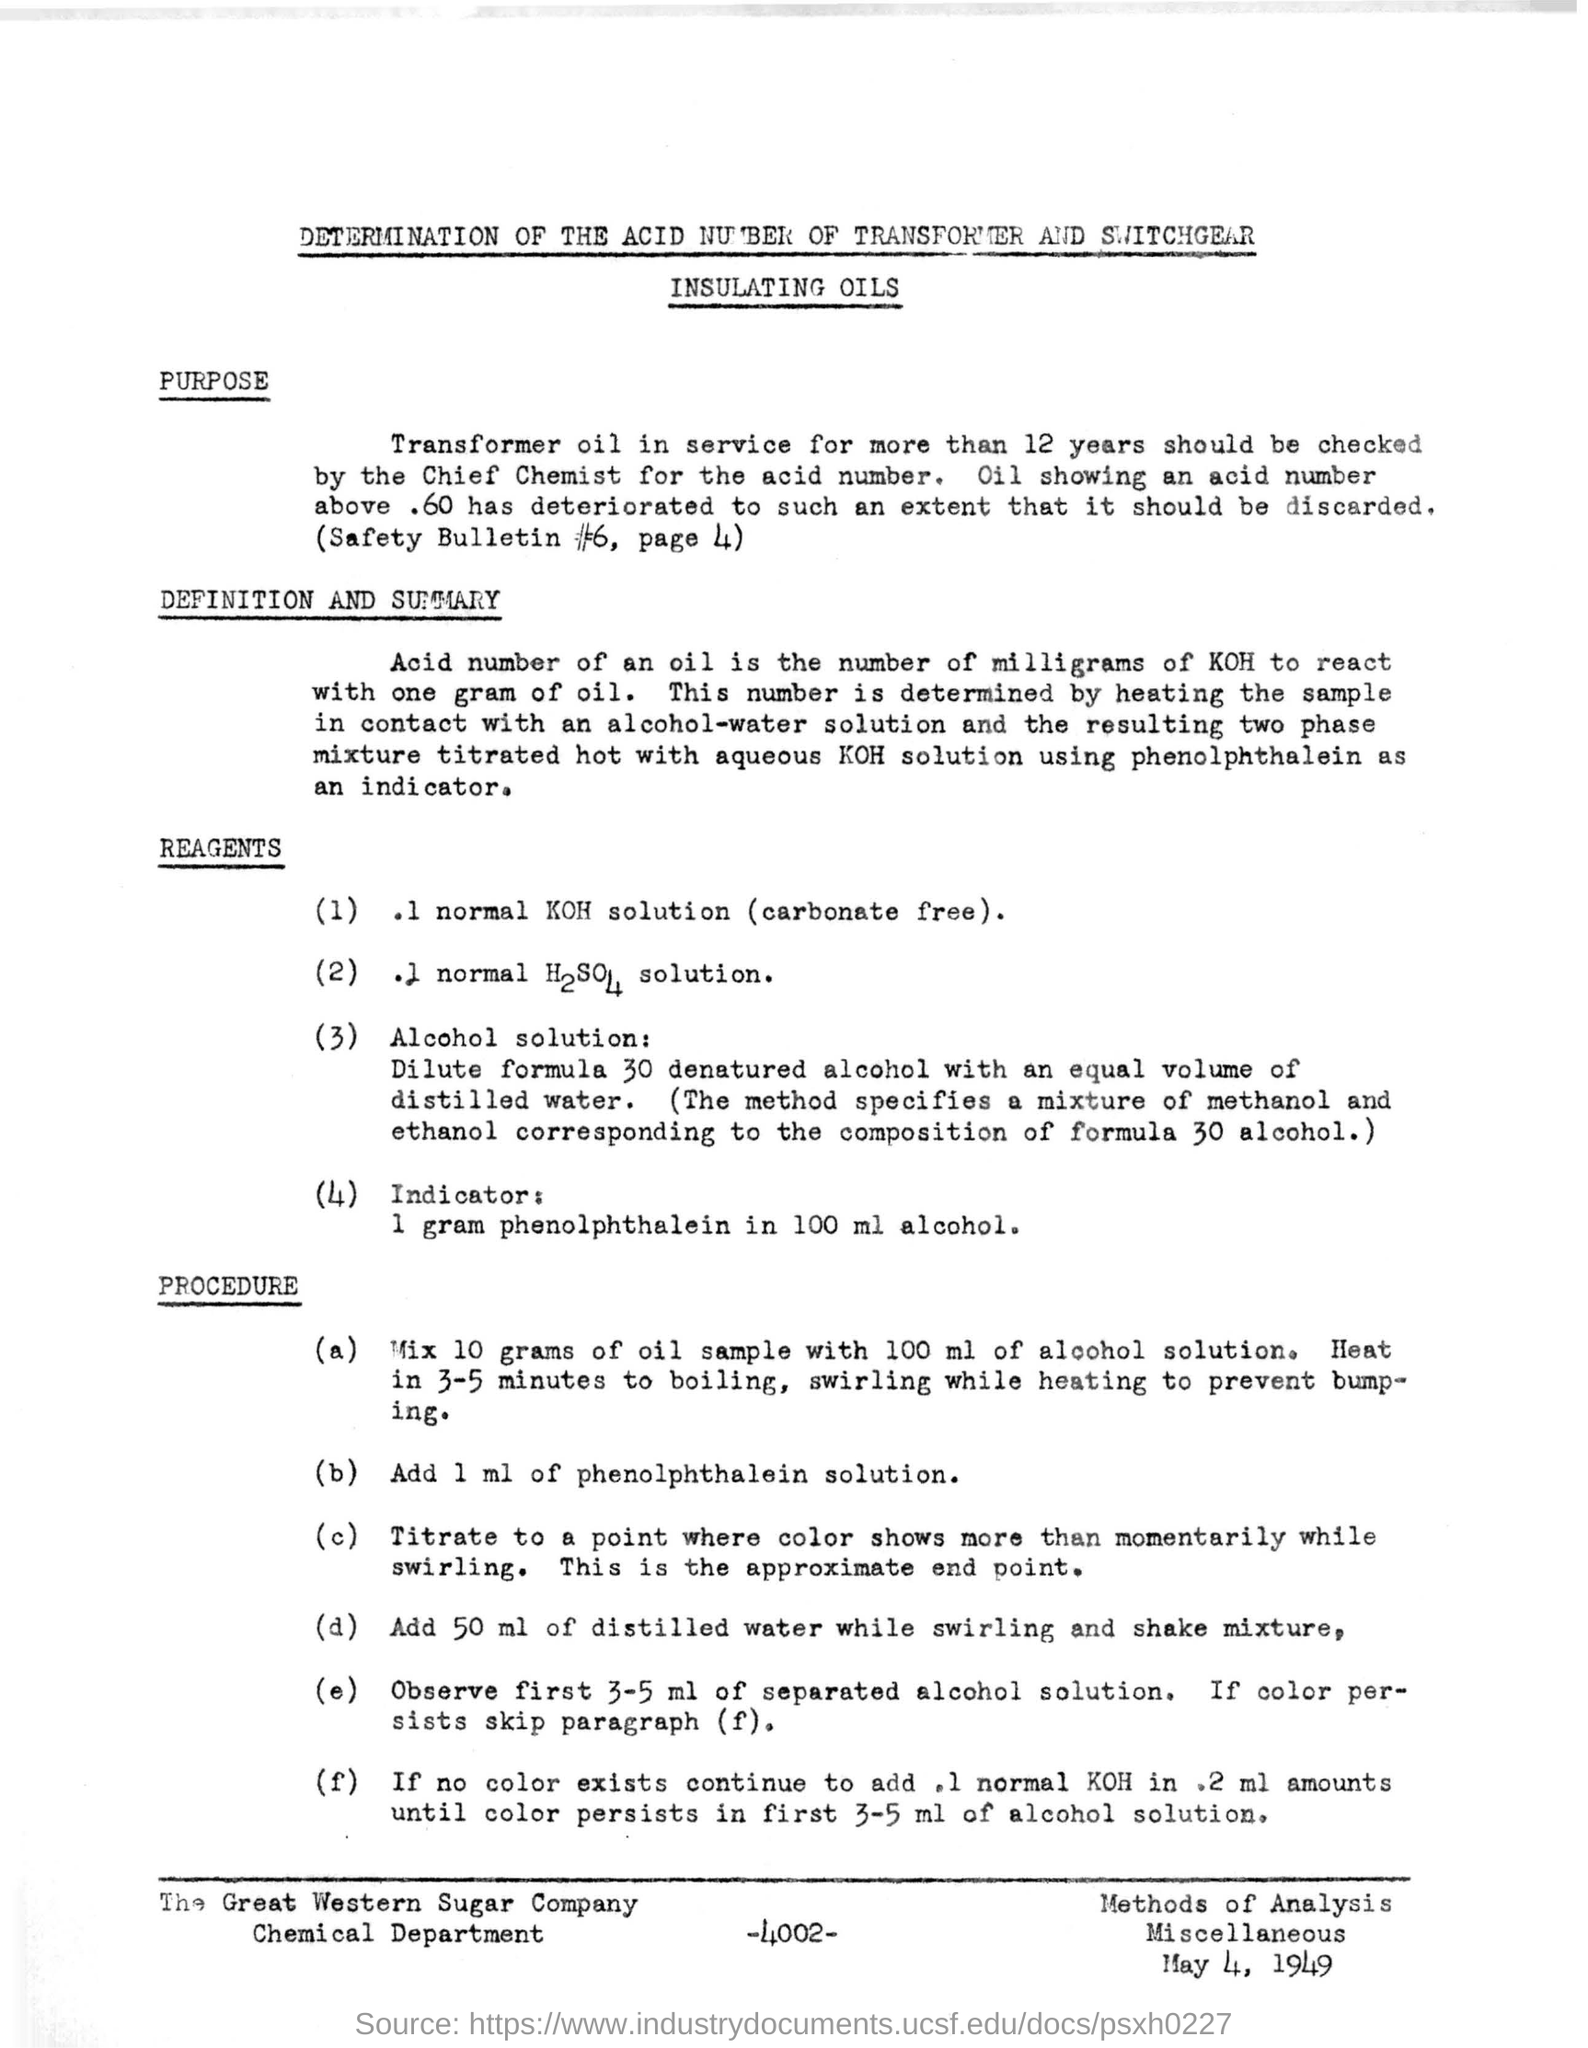Specify some key components in this picture. The document indicates that the company name at the bottom is "The Great Western Sugar Company. The date mentioned at the bottom of the document is May 4, 1949. The document at the top of the page concerns the determination of the acid number of transformer and switchgear insulating oils. The number written at the bottom of the document is -4002-. 